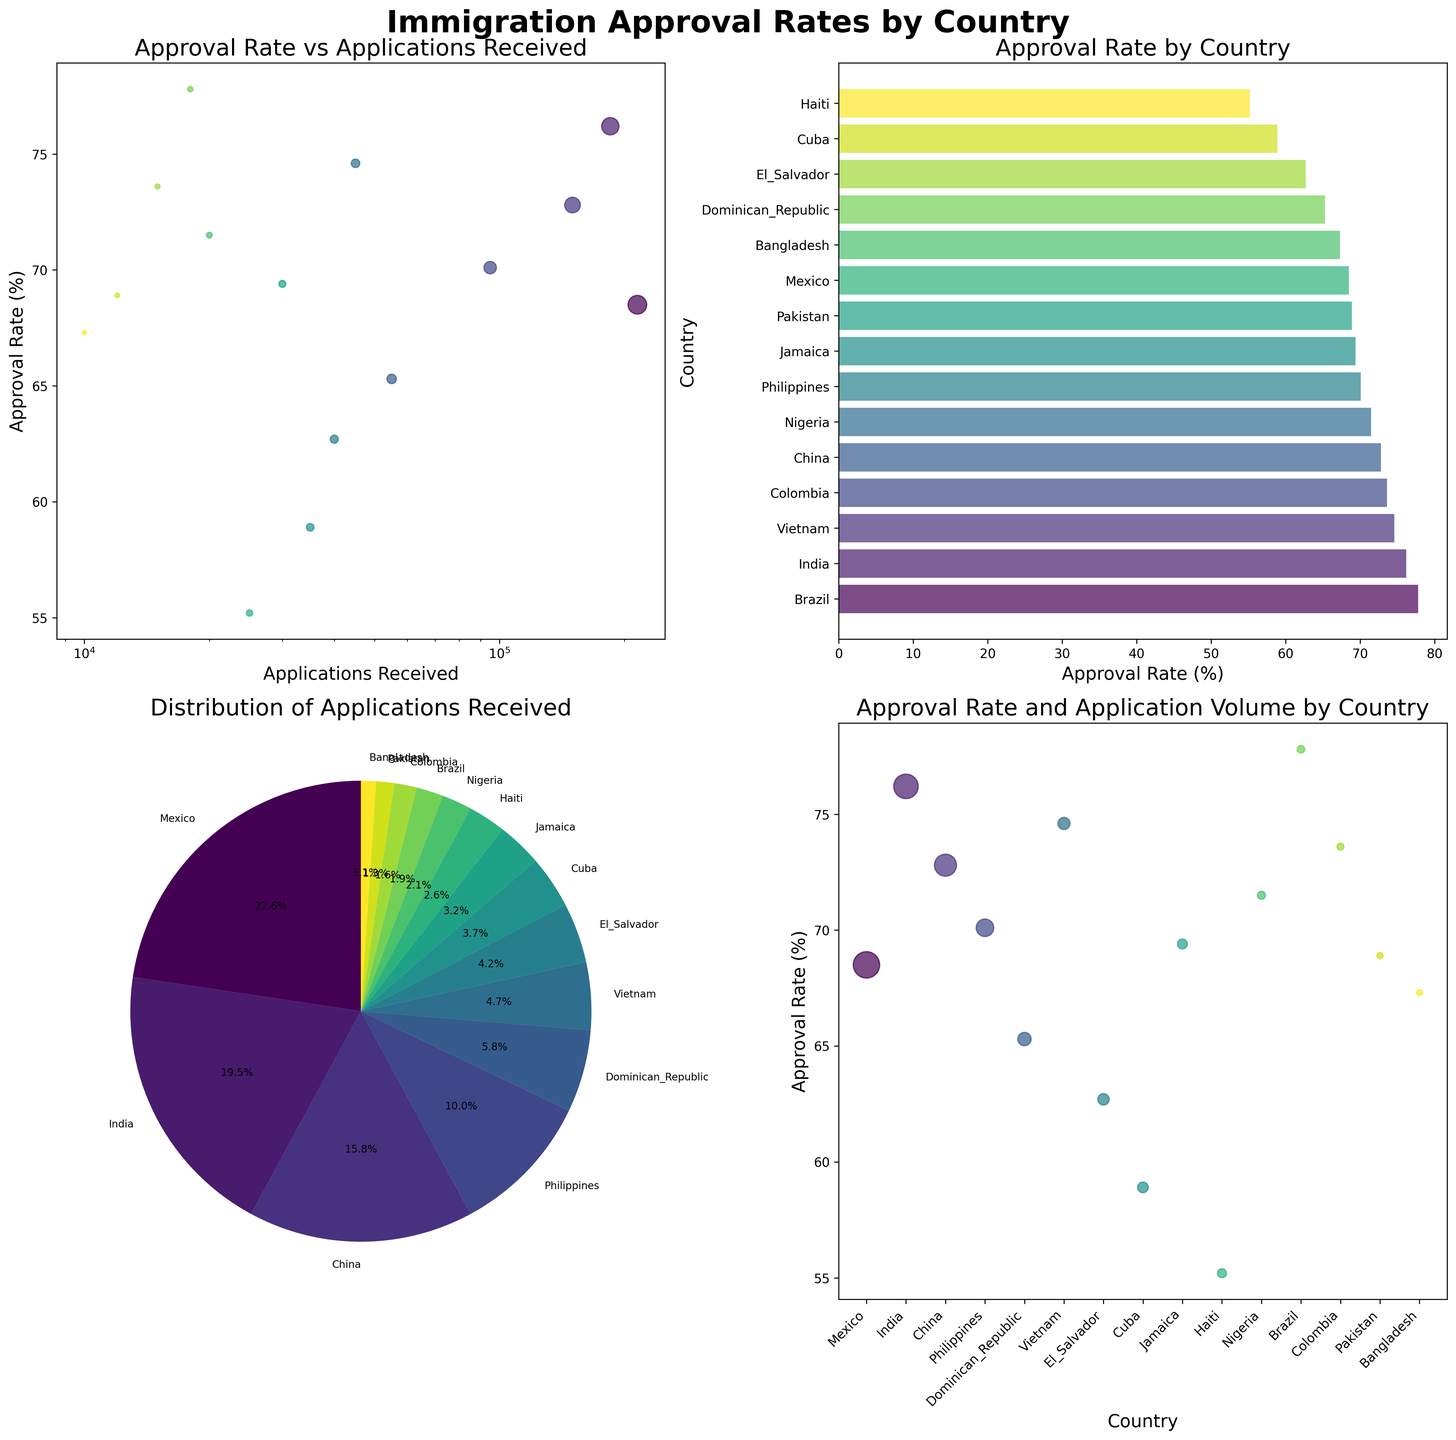How many countries are represented in the bar plot of "Approval Rate by Country"? The y-axis of the bar plot lists the names of all the countries represented. We can count the number of bars to determine the number of countries.
Answer: 15 Which country has the highest approval rate according to the bar plot? In the bar plot, the bars are sorted by approval rate in descending order. The topmost bar represents the country with the highest approval rate.
Answer: Brazil What is the approval rate of Pakistan? The bar plot shows the approval rates for each country. Find Pakistan in the plot, and its corresponding bar indicates the approval rate.
Answer: 68.9% Which country received the most applications? The pie chart shows the distribution of applications received by country. The largest slice represents the country with the most applications.
Answer: Mexico What is the approval rate vs. applications received trend visible in the scatter plot? The scatter plot titled "Approval Rate vs Applications Received" provides this information. Observing the points, we can note whether there is any apparent trend between these two variables.
Answer: No clear trend Which country has the lowest approval rate, and what is that rate? The bar plot in the upper right, titled "Approval Rate by Country," arranges countries based on approval rates. The bottom bar represents the country with the lowest approval rate.
Answer: Haiti, 55.2% Compare the approval rate and application volume of China and India. The scatter plot in the lower right shows both approval rate and application volume using the size of the points. By locating China and India on this plot, we can compare both metrics.
Answer: China: 72.8%, 150,000 applications; India: 76.2%, 185,000 applications What percentage of total applications were received by the top three countries? The pie chart represents the distribution of applications. Identify the three largest slices, sum their percentages, and that'll give the combined percentage.
Answer: Approximately 64% (Mexico, India, China) Between Brazil and Nigeria, which country has a higher approval rate, and by how much? Refer to the bar plot. Locate Brazil and Nigeria, and compare their approval rates. Subtract the lower rate from the higher rate to find the difference.
Answer: Brazil has a higher rate by 6.3% Is there a relationship between the number of applications received and the approval rate? This can be inferred from examining the scatter plot titled "Approval Rate vs Applications Received." Assess whether there's a visible pattern or correlation between the number of applications and the approval rate.
Answer: No clear relationship 